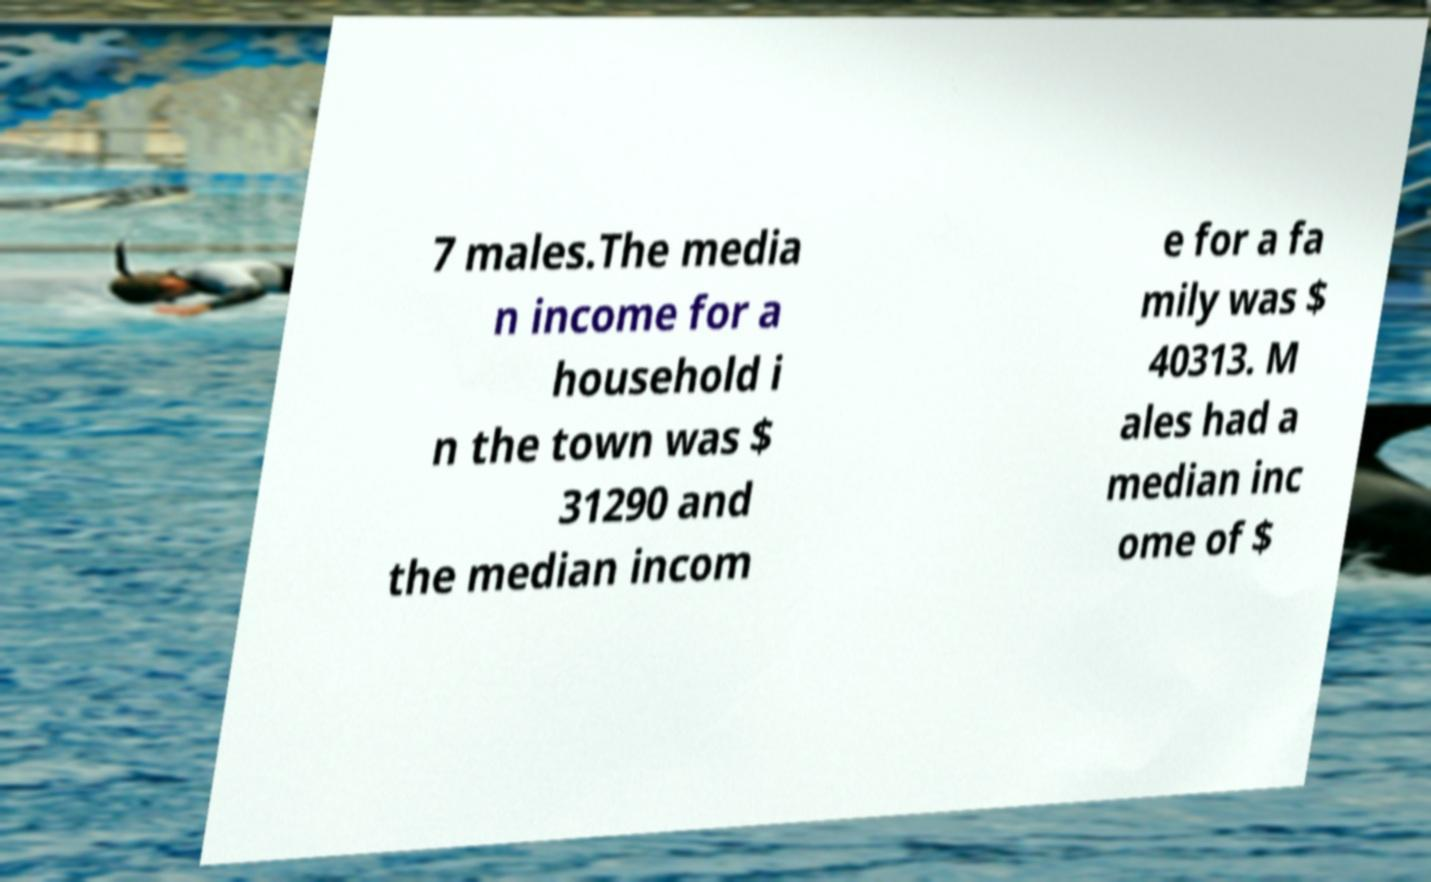Could you assist in decoding the text presented in this image and type it out clearly? 7 males.The media n income for a household i n the town was $ 31290 and the median incom e for a fa mily was $ 40313. M ales had a median inc ome of $ 